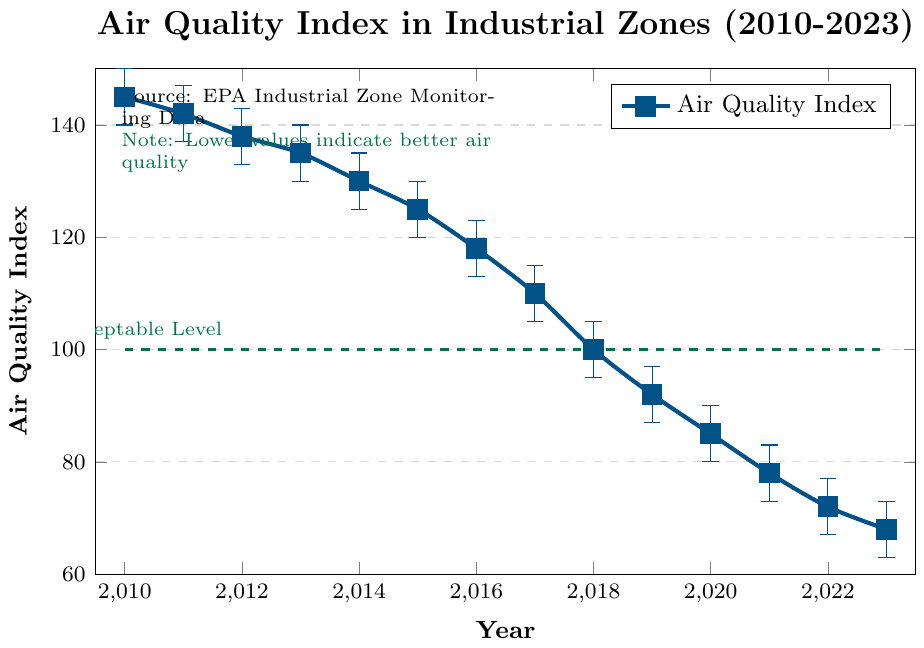What's the difference in the Air Quality Index between 2010 and 2023? To find the difference, subtract the Air Quality Index of 2023 from that of 2010. The values are 145 (2010) and 68 (2023). Calculation: 145 - 68 = 77
Answer: 77 In which year did the Air Quality Index first drop below 100? Look through the years on the x-axis and find the first year when the Air Quality Index (y-axis) dropped below 100. According to the plot, this occurred in 2018.
Answer: 2018 Compare the Air Quality Index between 2016 and 2019. Which year had a lower index? Locate the indices for 2016 and 2019. In 2016, the index is 118, and in 2019, it's 92. Since 92 is less than 118, the index was lower in 2019.
Answer: 2019 Is the Air Quality Index in 2023 above or below the acceptable level indicated in the figure? Refer to the dashed line labeled "Acceptable Level" at a value of 100 on the y-axis. The Air Quality Index for 2023 is at 68, which is below 100.
Answer: Below What is the average Air Quality Index between 2020 and 2023? Identify the values from 2020 to 2023: 85 (2020), 78 (2021), 72 (2022), 68 (2023). Sum these values: 85 + 78 + 72 + 68 = 303. Calculate the average: 303 / 4 = 75.75
Answer: 75.75 During which year did the Air Quality Index see the most significant drop compared to the previous year? Calculate the yearly differences: 2011-2010 = 3, 2012-2011 = 4, 2013-2012 = 3, 2014-2013 = 5, 2015-2014 = 5, 2016-2015 = 7, 2017-2016 = 8, 2018-2017 = 10, 2019-2018 = 8, 2020-2019 = 7, 2021-2020 = 7, 2022-2021 = 6, 2023-2022 = 4. The largest drop is 10 (2018-2017).
Answer: 2018 In which year did the Air Quality Index first reach a value below the acceptable level of 100? Identify the year when the Air Quality Index dropped below the acceptable level marked at 100. This first occurred in 2018.
Answer: 2018 What trend is observed in the Air Quality Index over the years 2010 to 2023? The plot shows a steady decline in the Air Quality Index values from 145 in 2010 to 68 in 2023, indicating an overall improvement in air quality over this period.
Answer: Declining trend How many years did it take for the Air Quality Index to fall from above 140 to below 80? First, identify the year the index was above 140 (2011) and the year it fell below 80 (2021). Calculate the time period: 2021 - 2011 = 10 years
Answer: 10 years 